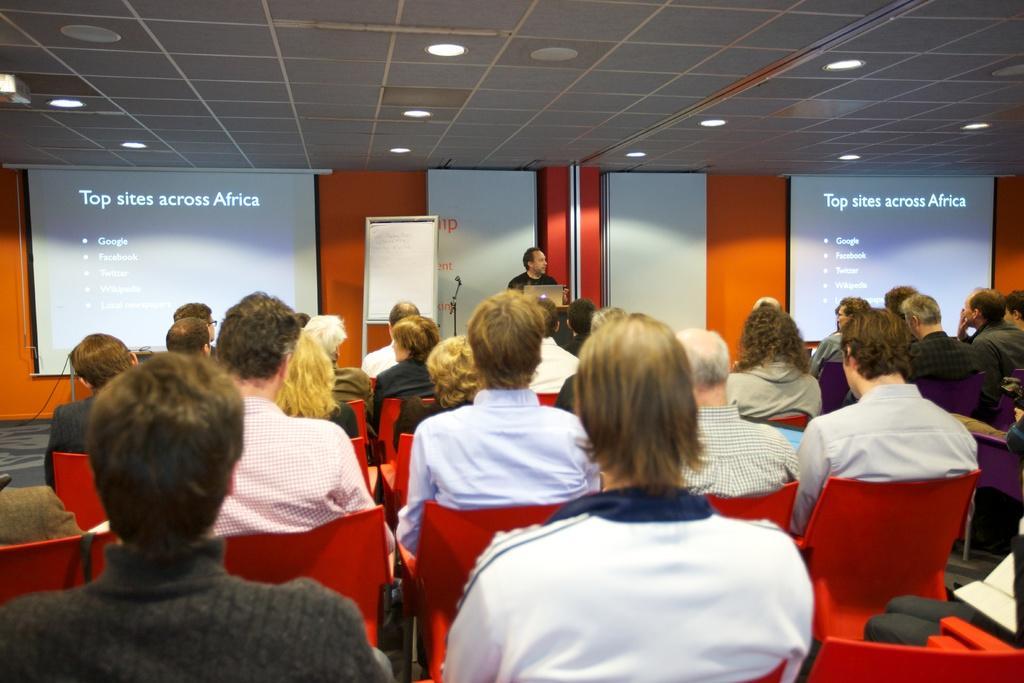Please provide a concise description of this image. In this picture we can see there is a group of people sitting on chairs and a person is standing. In front of the man there is a laptop and on the left side of the man there is a stand. Behind the people there are projector screens and an orange wall and at the top there are ceiling lights. 